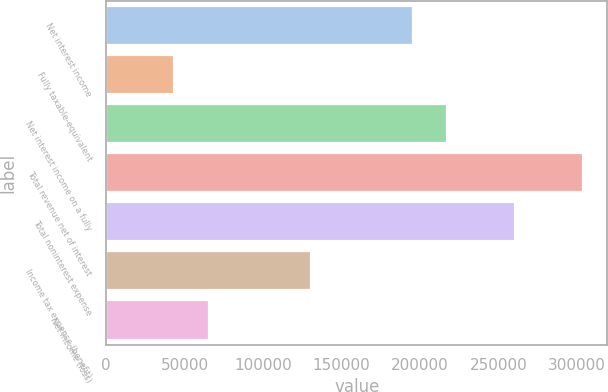Convert chart. <chart><loc_0><loc_0><loc_500><loc_500><bar_chart><fcel>Net interest income<fcel>Fully taxable-equivalent<fcel>Net interest income on a fully<fcel>Total revenue net of interest<fcel>Total noninterest expense<fcel>Income tax expense (benefit)<fcel>Net income (loss)<nl><fcel>195549<fcel>43481<fcel>217273<fcel>304169<fcel>260721<fcel>130377<fcel>65205<nl></chart> 